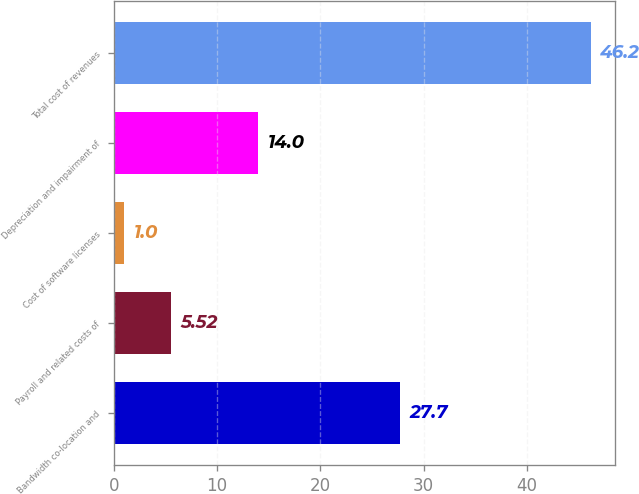<chart> <loc_0><loc_0><loc_500><loc_500><bar_chart><fcel>Bandwidth co-location and<fcel>Payroll and related costs of<fcel>Cost of software licenses<fcel>Depreciation and impairment of<fcel>Total cost of revenues<nl><fcel>27.7<fcel>5.52<fcel>1<fcel>14<fcel>46.2<nl></chart> 